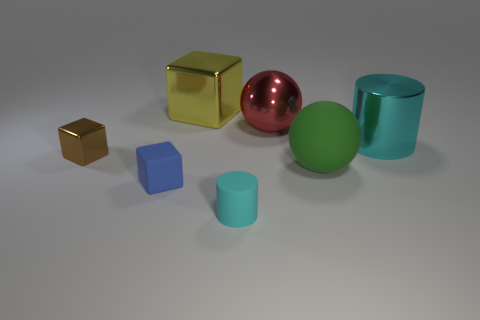The metal object that is in front of the big metal thing that is in front of the metal ball is what shape?
Make the answer very short. Cube. What number of blocks are behind the small blue rubber cube?
Provide a succinct answer. 2. Is the material of the small brown cube the same as the cyan object that is right of the tiny cyan rubber object?
Ensure brevity in your answer.  Yes. Are there any yellow cubes that have the same size as the green rubber object?
Your response must be concise. Yes. Are there an equal number of tiny things that are behind the big shiny ball and big brown objects?
Your answer should be very brief. Yes. What is the size of the blue object?
Provide a short and direct response. Small. How many tiny blue rubber objects are left of the big ball that is behind the green rubber sphere?
Your answer should be very brief. 1. There is a object that is behind the matte ball and right of the large red metal thing; what shape is it?
Provide a short and direct response. Cylinder. What number of metal cylinders have the same color as the small rubber cylinder?
Your response must be concise. 1. Are there any cylinders right of the small rubber object that is right of the big metal thing on the left side of the small cyan cylinder?
Provide a succinct answer. Yes. 